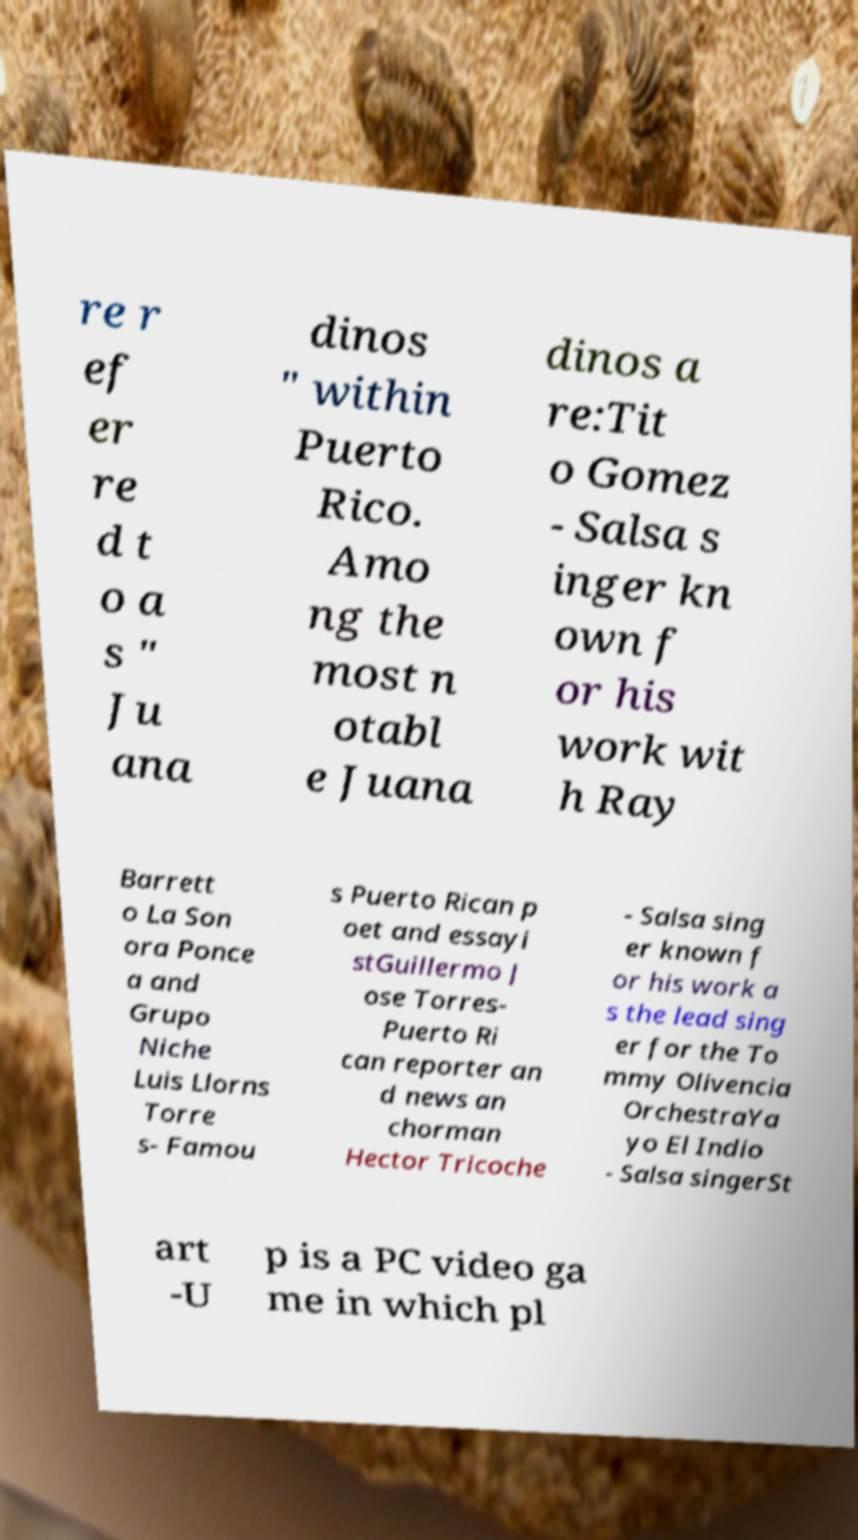For documentation purposes, I need the text within this image transcribed. Could you provide that? re r ef er re d t o a s " Ju ana dinos " within Puerto Rico. Amo ng the most n otabl e Juana dinos a re:Tit o Gomez - Salsa s inger kn own f or his work wit h Ray Barrett o La Son ora Ponce a and Grupo Niche Luis Llorns Torre s- Famou s Puerto Rican p oet and essayi stGuillermo J ose Torres- Puerto Ri can reporter an d news an chorman Hector Tricoche - Salsa sing er known f or his work a s the lead sing er for the To mmy Olivencia OrchestraYa yo El Indio - Salsa singerSt art -U p is a PC video ga me in which pl 